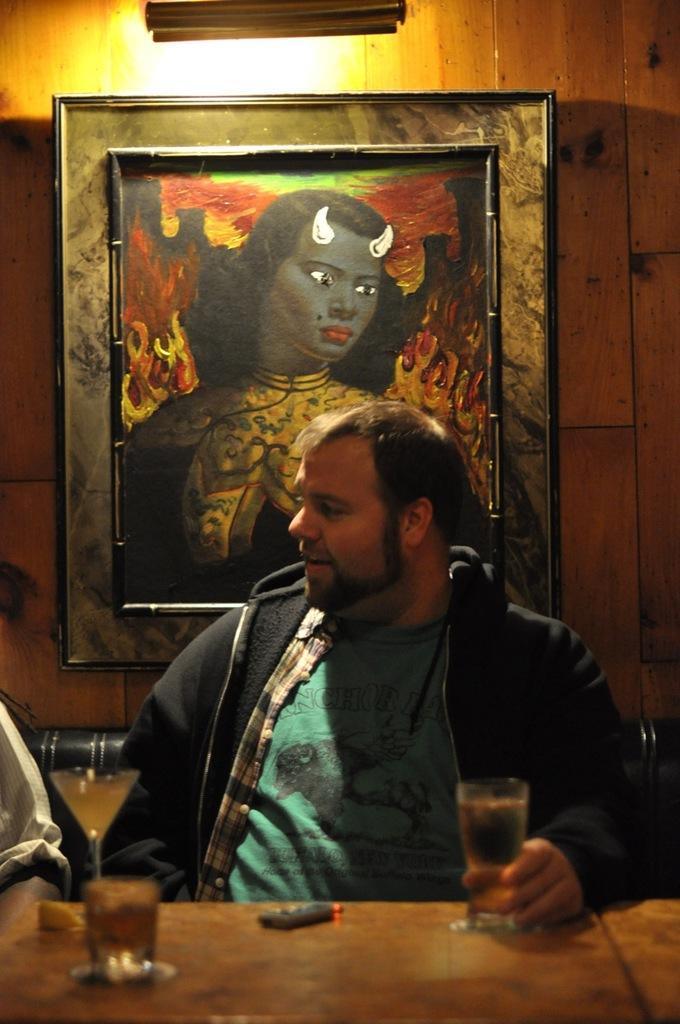Please provide a concise description of this image. This picture shows a man sitting in the chair in front of a table on which some glasses were placed. He is holding the glass. In the background there is a photo frame with demon attached to the wall here. 